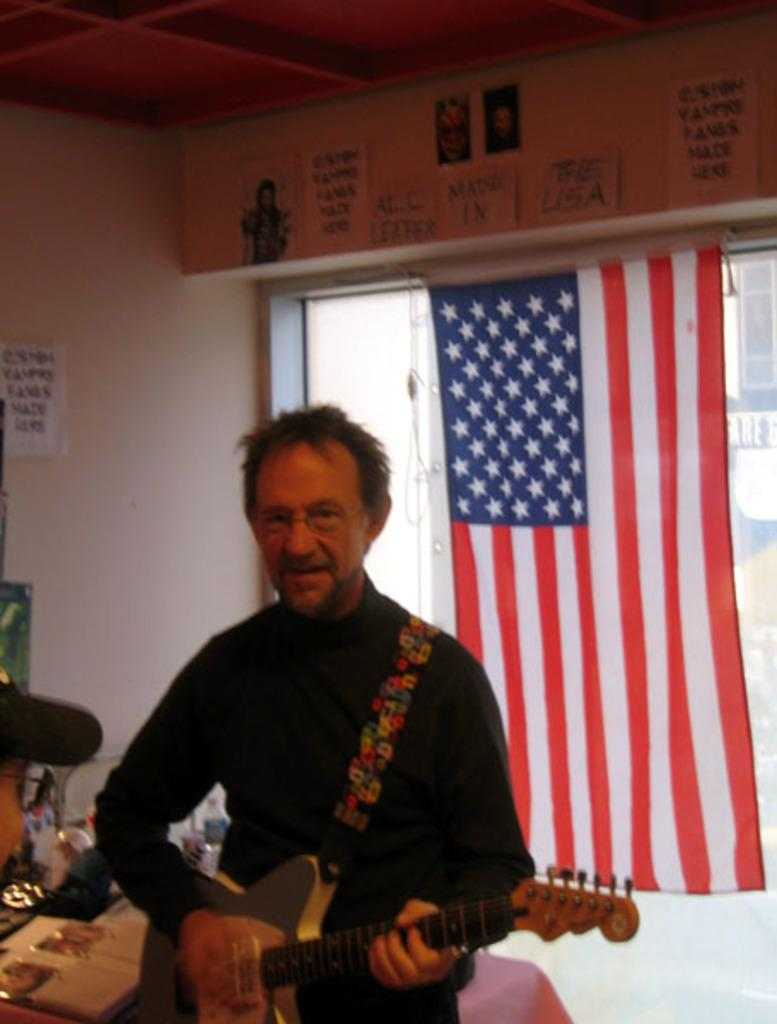Who is present in the image? There is a man in the image. What is the man holding in the image? The man is holding a guitar. What can be seen in the background of the image? There is a flag in the background of the image. What type of fang can be seen in the man's hand in the image? There are no fangs present in the image; the man is holding a guitar. Is there a garden visible in the image? There is no garden present in the image. 